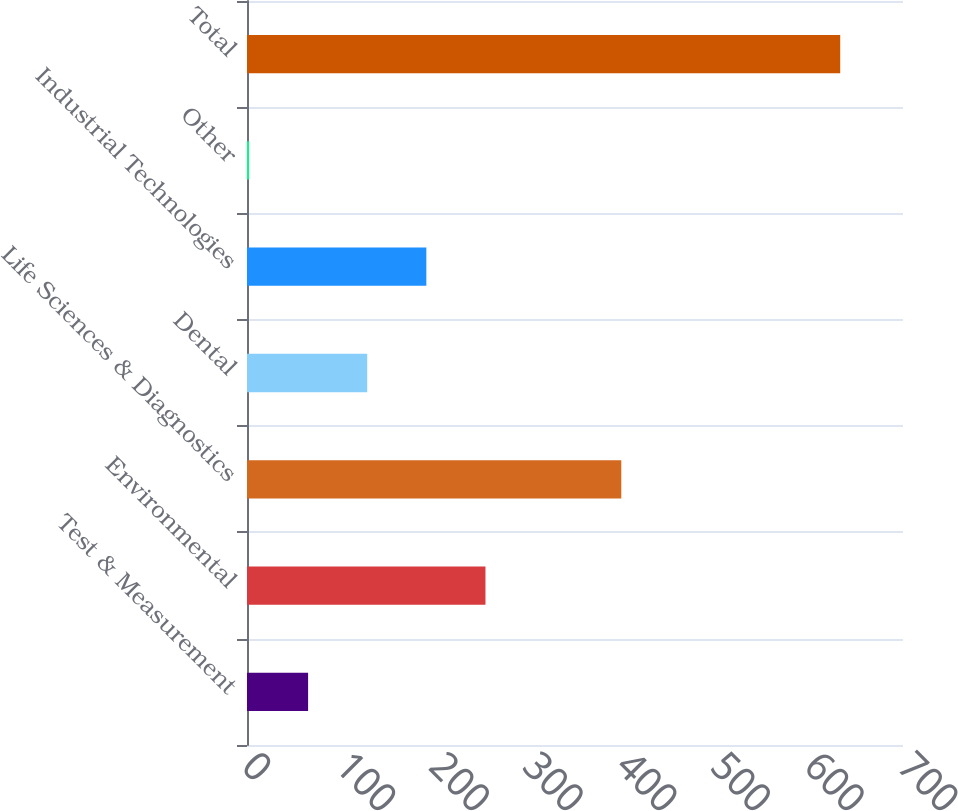Convert chart to OTSL. <chart><loc_0><loc_0><loc_500><loc_500><bar_chart><fcel>Test & Measurement<fcel>Environmental<fcel>Life Sciences & Diagnostics<fcel>Dental<fcel>Industrial Technologies<fcel>Other<fcel>Total<nl><fcel>65.19<fcel>254.46<fcel>399.4<fcel>128.28<fcel>191.37<fcel>2.1<fcel>633<nl></chart> 